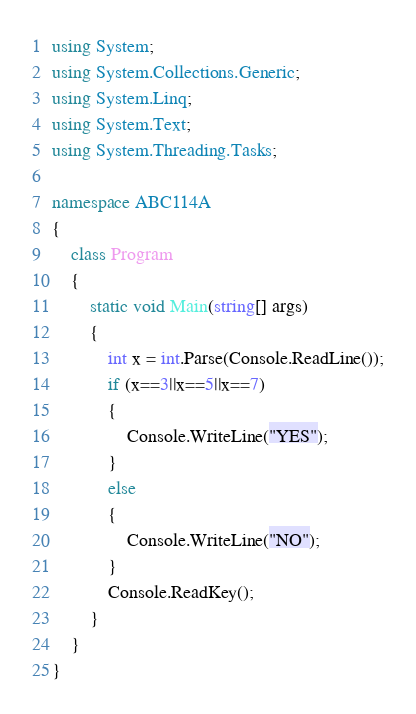Convert code to text. <code><loc_0><loc_0><loc_500><loc_500><_C#_>using System;
using System.Collections.Generic;
using System.Linq;
using System.Text;
using System.Threading.Tasks;

namespace ABC114A
{
    class Program
    {
        static void Main(string[] args)
        {
            int x = int.Parse(Console.ReadLine());
            if (x==3||x==5||x==7)
            {
                Console.WriteLine("YES");
            }
            else
            {
                Console.WriteLine("NO");
            }
            Console.ReadKey();
        }
    }
}
</code> 